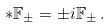Convert formula to latex. <formula><loc_0><loc_0><loc_500><loc_500>* \mathbb { F } _ { \pm } = \pm i \mathbb { F } _ { \pm } \, .</formula> 